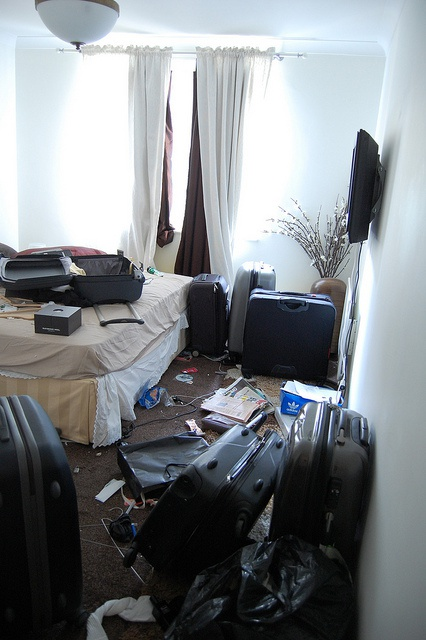Describe the objects in this image and their specific colors. I can see bed in darkgray, gray, and lightgray tones, suitcase in darkgray, black, gray, and darkblue tones, suitcase in darkgray, black, and gray tones, suitcase in darkgray, black, gray, and darkblue tones, and suitcase in darkgray, black, navy, and lightblue tones in this image. 